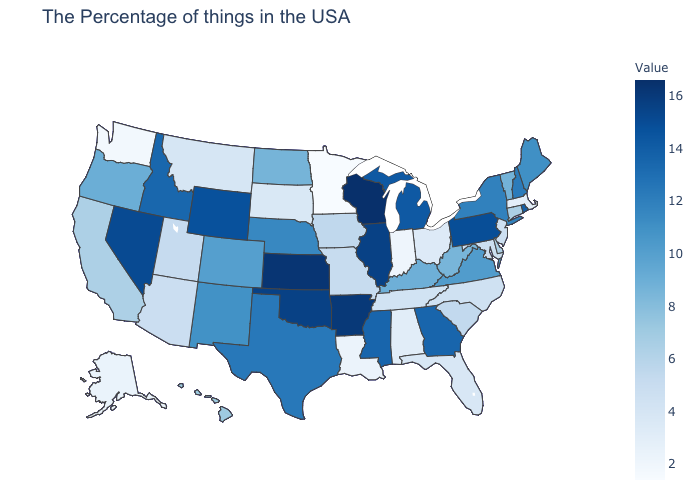Does Nevada have the highest value in the West?
Give a very brief answer. Yes. Among the states that border Oregon , which have the highest value?
Concise answer only. Nevada. Among the states that border New Mexico , which have the lowest value?
Keep it brief. Arizona. Among the states that border Rhode Island , which have the lowest value?
Answer briefly. Massachusetts. Does Colorado have a lower value than Indiana?
Give a very brief answer. No. Which states have the lowest value in the USA?
Answer briefly. Minnesota. Does Arizona have a higher value than Vermont?
Keep it brief. No. 